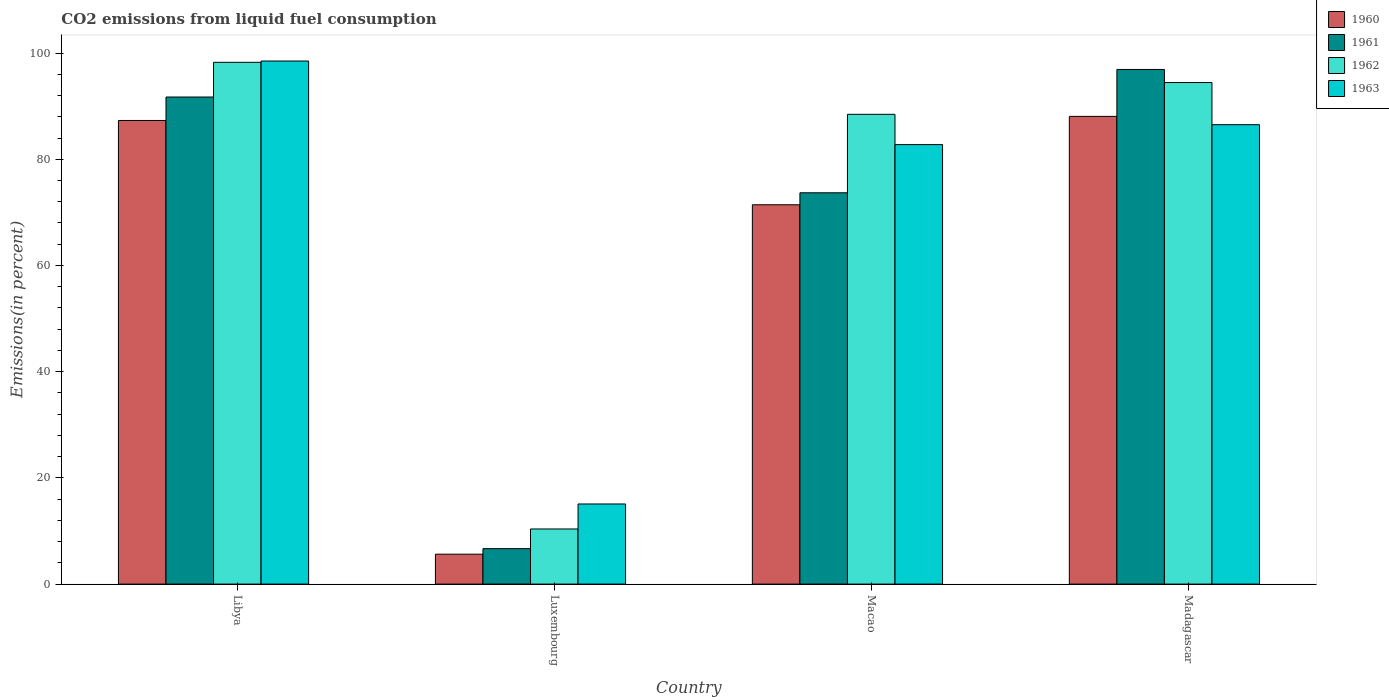How many bars are there on the 3rd tick from the left?
Provide a succinct answer. 4. What is the label of the 1st group of bars from the left?
Make the answer very short. Libya. What is the total CO2 emitted in 1963 in Libya?
Keep it short and to the point. 98.5. Across all countries, what is the maximum total CO2 emitted in 1962?
Your answer should be very brief. 98.25. Across all countries, what is the minimum total CO2 emitted in 1962?
Offer a terse response. 10.38. In which country was the total CO2 emitted in 1963 maximum?
Offer a terse response. Libya. In which country was the total CO2 emitted in 1961 minimum?
Provide a succinct answer. Luxembourg. What is the total total CO2 emitted in 1961 in the graph?
Give a very brief answer. 268.98. What is the difference between the total CO2 emitted in 1961 in Luxembourg and that in Madagascar?
Your answer should be very brief. -90.23. What is the difference between the total CO2 emitted in 1962 in Luxembourg and the total CO2 emitted in 1961 in Madagascar?
Provide a succinct answer. -86.53. What is the average total CO2 emitted in 1963 per country?
Your answer should be compact. 70.71. What is the difference between the total CO2 emitted of/in 1962 and total CO2 emitted of/in 1961 in Macao?
Your answer should be very brief. 14.78. What is the ratio of the total CO2 emitted in 1962 in Macao to that in Madagascar?
Ensure brevity in your answer.  0.94. Is the total CO2 emitted in 1960 in Libya less than that in Macao?
Your answer should be compact. No. What is the difference between the highest and the second highest total CO2 emitted in 1960?
Give a very brief answer. 16.64. What is the difference between the highest and the lowest total CO2 emitted in 1960?
Ensure brevity in your answer.  82.44. In how many countries, is the total CO2 emitted in 1962 greater than the average total CO2 emitted in 1962 taken over all countries?
Offer a very short reply. 3. Is it the case that in every country, the sum of the total CO2 emitted in 1962 and total CO2 emitted in 1961 is greater than the sum of total CO2 emitted in 1960 and total CO2 emitted in 1963?
Your answer should be very brief. No. How many bars are there?
Provide a succinct answer. 16. Are all the bars in the graph horizontal?
Give a very brief answer. No. Are the values on the major ticks of Y-axis written in scientific E-notation?
Your answer should be compact. No. Does the graph contain any zero values?
Give a very brief answer. No. Where does the legend appear in the graph?
Your answer should be very brief. Top right. How many legend labels are there?
Make the answer very short. 4. What is the title of the graph?
Provide a succinct answer. CO2 emissions from liquid fuel consumption. What is the label or title of the Y-axis?
Offer a terse response. Emissions(in percent). What is the Emissions(in percent) of 1960 in Libya?
Your answer should be very brief. 87.3. What is the Emissions(in percent) in 1961 in Libya?
Provide a succinct answer. 91.72. What is the Emissions(in percent) in 1962 in Libya?
Your answer should be compact. 98.25. What is the Emissions(in percent) of 1963 in Libya?
Make the answer very short. 98.5. What is the Emissions(in percent) of 1960 in Luxembourg?
Your answer should be very brief. 5.64. What is the Emissions(in percent) of 1961 in Luxembourg?
Your response must be concise. 6.68. What is the Emissions(in percent) of 1962 in Luxembourg?
Ensure brevity in your answer.  10.38. What is the Emissions(in percent) of 1963 in Luxembourg?
Keep it short and to the point. 15.09. What is the Emissions(in percent) in 1960 in Macao?
Give a very brief answer. 71.43. What is the Emissions(in percent) in 1961 in Macao?
Provide a succinct answer. 73.68. What is the Emissions(in percent) in 1962 in Macao?
Keep it short and to the point. 88.46. What is the Emissions(in percent) in 1963 in Macao?
Provide a succinct answer. 82.76. What is the Emissions(in percent) of 1960 in Madagascar?
Make the answer very short. 88.07. What is the Emissions(in percent) of 1961 in Madagascar?
Your response must be concise. 96.91. What is the Emissions(in percent) of 1962 in Madagascar?
Give a very brief answer. 94.44. What is the Emissions(in percent) of 1963 in Madagascar?
Keep it short and to the point. 86.51. Across all countries, what is the maximum Emissions(in percent) of 1960?
Offer a terse response. 88.07. Across all countries, what is the maximum Emissions(in percent) of 1961?
Make the answer very short. 96.91. Across all countries, what is the maximum Emissions(in percent) of 1962?
Offer a terse response. 98.25. Across all countries, what is the maximum Emissions(in percent) of 1963?
Provide a short and direct response. 98.5. Across all countries, what is the minimum Emissions(in percent) in 1960?
Provide a short and direct response. 5.64. Across all countries, what is the minimum Emissions(in percent) in 1961?
Provide a short and direct response. 6.68. Across all countries, what is the minimum Emissions(in percent) of 1962?
Offer a terse response. 10.38. Across all countries, what is the minimum Emissions(in percent) of 1963?
Offer a terse response. 15.09. What is the total Emissions(in percent) of 1960 in the graph?
Keep it short and to the point. 252.44. What is the total Emissions(in percent) in 1961 in the graph?
Offer a very short reply. 268.98. What is the total Emissions(in percent) in 1962 in the graph?
Provide a short and direct response. 291.54. What is the total Emissions(in percent) of 1963 in the graph?
Give a very brief answer. 282.85. What is the difference between the Emissions(in percent) in 1960 in Libya and that in Luxembourg?
Ensure brevity in your answer.  81.67. What is the difference between the Emissions(in percent) of 1961 in Libya and that in Luxembourg?
Provide a succinct answer. 85.04. What is the difference between the Emissions(in percent) in 1962 in Libya and that in Luxembourg?
Offer a very short reply. 87.87. What is the difference between the Emissions(in percent) in 1963 in Libya and that in Luxembourg?
Offer a terse response. 83.41. What is the difference between the Emissions(in percent) of 1960 in Libya and that in Macao?
Keep it short and to the point. 15.87. What is the difference between the Emissions(in percent) in 1961 in Libya and that in Macao?
Give a very brief answer. 18.03. What is the difference between the Emissions(in percent) of 1962 in Libya and that in Macao?
Ensure brevity in your answer.  9.79. What is the difference between the Emissions(in percent) in 1963 in Libya and that in Macao?
Offer a very short reply. 15.74. What is the difference between the Emissions(in percent) in 1960 in Libya and that in Madagascar?
Make the answer very short. -0.77. What is the difference between the Emissions(in percent) in 1961 in Libya and that in Madagascar?
Offer a very short reply. -5.19. What is the difference between the Emissions(in percent) in 1962 in Libya and that in Madagascar?
Your response must be concise. 3.81. What is the difference between the Emissions(in percent) of 1963 in Libya and that in Madagascar?
Give a very brief answer. 11.99. What is the difference between the Emissions(in percent) of 1960 in Luxembourg and that in Macao?
Offer a terse response. -65.79. What is the difference between the Emissions(in percent) in 1961 in Luxembourg and that in Macao?
Ensure brevity in your answer.  -67.01. What is the difference between the Emissions(in percent) of 1962 in Luxembourg and that in Macao?
Your response must be concise. -78.08. What is the difference between the Emissions(in percent) in 1963 in Luxembourg and that in Macao?
Your answer should be very brief. -67.67. What is the difference between the Emissions(in percent) of 1960 in Luxembourg and that in Madagascar?
Ensure brevity in your answer.  -82.44. What is the difference between the Emissions(in percent) of 1961 in Luxembourg and that in Madagascar?
Your answer should be very brief. -90.23. What is the difference between the Emissions(in percent) of 1962 in Luxembourg and that in Madagascar?
Ensure brevity in your answer.  -84.06. What is the difference between the Emissions(in percent) of 1963 in Luxembourg and that in Madagascar?
Your answer should be very brief. -71.42. What is the difference between the Emissions(in percent) in 1960 in Macao and that in Madagascar?
Give a very brief answer. -16.64. What is the difference between the Emissions(in percent) of 1961 in Macao and that in Madagascar?
Make the answer very short. -23.22. What is the difference between the Emissions(in percent) in 1962 in Macao and that in Madagascar?
Make the answer very short. -5.98. What is the difference between the Emissions(in percent) in 1963 in Macao and that in Madagascar?
Your answer should be compact. -3.75. What is the difference between the Emissions(in percent) in 1960 in Libya and the Emissions(in percent) in 1961 in Luxembourg?
Ensure brevity in your answer.  80.63. What is the difference between the Emissions(in percent) in 1960 in Libya and the Emissions(in percent) in 1962 in Luxembourg?
Your answer should be compact. 76.92. What is the difference between the Emissions(in percent) of 1960 in Libya and the Emissions(in percent) of 1963 in Luxembourg?
Provide a short and direct response. 72.22. What is the difference between the Emissions(in percent) of 1961 in Libya and the Emissions(in percent) of 1962 in Luxembourg?
Offer a very short reply. 81.34. What is the difference between the Emissions(in percent) in 1961 in Libya and the Emissions(in percent) in 1963 in Luxembourg?
Offer a very short reply. 76.63. What is the difference between the Emissions(in percent) of 1962 in Libya and the Emissions(in percent) of 1963 in Luxembourg?
Make the answer very short. 83.17. What is the difference between the Emissions(in percent) in 1960 in Libya and the Emissions(in percent) in 1961 in Macao?
Keep it short and to the point. 13.62. What is the difference between the Emissions(in percent) in 1960 in Libya and the Emissions(in percent) in 1962 in Macao?
Make the answer very short. -1.16. What is the difference between the Emissions(in percent) of 1960 in Libya and the Emissions(in percent) of 1963 in Macao?
Give a very brief answer. 4.54. What is the difference between the Emissions(in percent) of 1961 in Libya and the Emissions(in percent) of 1962 in Macao?
Provide a succinct answer. 3.26. What is the difference between the Emissions(in percent) in 1961 in Libya and the Emissions(in percent) in 1963 in Macao?
Provide a succinct answer. 8.96. What is the difference between the Emissions(in percent) of 1962 in Libya and the Emissions(in percent) of 1963 in Macao?
Provide a succinct answer. 15.49. What is the difference between the Emissions(in percent) in 1960 in Libya and the Emissions(in percent) in 1961 in Madagascar?
Keep it short and to the point. -9.61. What is the difference between the Emissions(in percent) in 1960 in Libya and the Emissions(in percent) in 1962 in Madagascar?
Your response must be concise. -7.14. What is the difference between the Emissions(in percent) in 1960 in Libya and the Emissions(in percent) in 1963 in Madagascar?
Make the answer very short. 0.79. What is the difference between the Emissions(in percent) in 1961 in Libya and the Emissions(in percent) in 1962 in Madagascar?
Your answer should be compact. -2.73. What is the difference between the Emissions(in percent) in 1961 in Libya and the Emissions(in percent) in 1963 in Madagascar?
Offer a very short reply. 5.21. What is the difference between the Emissions(in percent) in 1962 in Libya and the Emissions(in percent) in 1963 in Madagascar?
Your response must be concise. 11.74. What is the difference between the Emissions(in percent) of 1960 in Luxembourg and the Emissions(in percent) of 1961 in Macao?
Provide a succinct answer. -68.05. What is the difference between the Emissions(in percent) of 1960 in Luxembourg and the Emissions(in percent) of 1962 in Macao?
Your answer should be very brief. -82.83. What is the difference between the Emissions(in percent) of 1960 in Luxembourg and the Emissions(in percent) of 1963 in Macao?
Give a very brief answer. -77.12. What is the difference between the Emissions(in percent) of 1961 in Luxembourg and the Emissions(in percent) of 1962 in Macao?
Provide a succinct answer. -81.79. What is the difference between the Emissions(in percent) in 1961 in Luxembourg and the Emissions(in percent) in 1963 in Macao?
Provide a short and direct response. -76.08. What is the difference between the Emissions(in percent) of 1962 in Luxembourg and the Emissions(in percent) of 1963 in Macao?
Provide a succinct answer. -72.38. What is the difference between the Emissions(in percent) in 1960 in Luxembourg and the Emissions(in percent) in 1961 in Madagascar?
Your answer should be compact. -91.27. What is the difference between the Emissions(in percent) of 1960 in Luxembourg and the Emissions(in percent) of 1962 in Madagascar?
Make the answer very short. -88.81. What is the difference between the Emissions(in percent) in 1960 in Luxembourg and the Emissions(in percent) in 1963 in Madagascar?
Make the answer very short. -80.87. What is the difference between the Emissions(in percent) of 1961 in Luxembourg and the Emissions(in percent) of 1962 in Madagascar?
Your answer should be very brief. -87.77. What is the difference between the Emissions(in percent) in 1961 in Luxembourg and the Emissions(in percent) in 1963 in Madagascar?
Give a very brief answer. -79.83. What is the difference between the Emissions(in percent) in 1962 in Luxembourg and the Emissions(in percent) in 1963 in Madagascar?
Ensure brevity in your answer.  -76.13. What is the difference between the Emissions(in percent) in 1960 in Macao and the Emissions(in percent) in 1961 in Madagascar?
Provide a succinct answer. -25.48. What is the difference between the Emissions(in percent) in 1960 in Macao and the Emissions(in percent) in 1962 in Madagascar?
Keep it short and to the point. -23.02. What is the difference between the Emissions(in percent) in 1960 in Macao and the Emissions(in percent) in 1963 in Madagascar?
Keep it short and to the point. -15.08. What is the difference between the Emissions(in percent) in 1961 in Macao and the Emissions(in percent) in 1962 in Madagascar?
Your response must be concise. -20.76. What is the difference between the Emissions(in percent) of 1961 in Macao and the Emissions(in percent) of 1963 in Madagascar?
Offer a terse response. -12.82. What is the difference between the Emissions(in percent) in 1962 in Macao and the Emissions(in percent) in 1963 in Madagascar?
Make the answer very short. 1.95. What is the average Emissions(in percent) in 1960 per country?
Provide a succinct answer. 63.11. What is the average Emissions(in percent) of 1961 per country?
Offer a very short reply. 67.25. What is the average Emissions(in percent) of 1962 per country?
Make the answer very short. 72.88. What is the average Emissions(in percent) of 1963 per country?
Your response must be concise. 70.71. What is the difference between the Emissions(in percent) of 1960 and Emissions(in percent) of 1961 in Libya?
Your answer should be compact. -4.42. What is the difference between the Emissions(in percent) in 1960 and Emissions(in percent) in 1962 in Libya?
Make the answer very short. -10.95. What is the difference between the Emissions(in percent) of 1960 and Emissions(in percent) of 1963 in Libya?
Provide a short and direct response. -11.19. What is the difference between the Emissions(in percent) in 1961 and Emissions(in percent) in 1962 in Libya?
Provide a succinct answer. -6.53. What is the difference between the Emissions(in percent) in 1961 and Emissions(in percent) in 1963 in Libya?
Your answer should be very brief. -6.78. What is the difference between the Emissions(in percent) in 1962 and Emissions(in percent) in 1963 in Libya?
Offer a very short reply. -0.24. What is the difference between the Emissions(in percent) in 1960 and Emissions(in percent) in 1961 in Luxembourg?
Your answer should be very brief. -1.04. What is the difference between the Emissions(in percent) of 1960 and Emissions(in percent) of 1962 in Luxembourg?
Give a very brief answer. -4.75. What is the difference between the Emissions(in percent) of 1960 and Emissions(in percent) of 1963 in Luxembourg?
Offer a very short reply. -9.45. What is the difference between the Emissions(in percent) of 1961 and Emissions(in percent) of 1962 in Luxembourg?
Your answer should be very brief. -3.71. What is the difference between the Emissions(in percent) of 1961 and Emissions(in percent) of 1963 in Luxembourg?
Your answer should be very brief. -8.41. What is the difference between the Emissions(in percent) in 1962 and Emissions(in percent) in 1963 in Luxembourg?
Your answer should be very brief. -4.71. What is the difference between the Emissions(in percent) in 1960 and Emissions(in percent) in 1961 in Macao?
Give a very brief answer. -2.26. What is the difference between the Emissions(in percent) of 1960 and Emissions(in percent) of 1962 in Macao?
Keep it short and to the point. -17.03. What is the difference between the Emissions(in percent) of 1960 and Emissions(in percent) of 1963 in Macao?
Provide a short and direct response. -11.33. What is the difference between the Emissions(in percent) in 1961 and Emissions(in percent) in 1962 in Macao?
Give a very brief answer. -14.78. What is the difference between the Emissions(in percent) in 1961 and Emissions(in percent) in 1963 in Macao?
Offer a terse response. -9.07. What is the difference between the Emissions(in percent) in 1962 and Emissions(in percent) in 1963 in Macao?
Your answer should be very brief. 5.7. What is the difference between the Emissions(in percent) of 1960 and Emissions(in percent) of 1961 in Madagascar?
Ensure brevity in your answer.  -8.83. What is the difference between the Emissions(in percent) in 1960 and Emissions(in percent) in 1962 in Madagascar?
Provide a short and direct response. -6.37. What is the difference between the Emissions(in percent) in 1960 and Emissions(in percent) in 1963 in Madagascar?
Provide a succinct answer. 1.57. What is the difference between the Emissions(in percent) of 1961 and Emissions(in percent) of 1962 in Madagascar?
Provide a succinct answer. 2.46. What is the difference between the Emissions(in percent) of 1961 and Emissions(in percent) of 1963 in Madagascar?
Your answer should be compact. 10.4. What is the difference between the Emissions(in percent) of 1962 and Emissions(in percent) of 1963 in Madagascar?
Ensure brevity in your answer.  7.94. What is the ratio of the Emissions(in percent) in 1960 in Libya to that in Luxembourg?
Make the answer very short. 15.49. What is the ratio of the Emissions(in percent) in 1961 in Libya to that in Luxembourg?
Offer a very short reply. 13.74. What is the ratio of the Emissions(in percent) in 1962 in Libya to that in Luxembourg?
Make the answer very short. 9.46. What is the ratio of the Emissions(in percent) in 1963 in Libya to that in Luxembourg?
Offer a very short reply. 6.53. What is the ratio of the Emissions(in percent) in 1960 in Libya to that in Macao?
Your response must be concise. 1.22. What is the ratio of the Emissions(in percent) of 1961 in Libya to that in Macao?
Ensure brevity in your answer.  1.24. What is the ratio of the Emissions(in percent) of 1962 in Libya to that in Macao?
Your response must be concise. 1.11. What is the ratio of the Emissions(in percent) of 1963 in Libya to that in Macao?
Your answer should be compact. 1.19. What is the ratio of the Emissions(in percent) of 1961 in Libya to that in Madagascar?
Provide a short and direct response. 0.95. What is the ratio of the Emissions(in percent) in 1962 in Libya to that in Madagascar?
Provide a short and direct response. 1.04. What is the ratio of the Emissions(in percent) of 1963 in Libya to that in Madagascar?
Keep it short and to the point. 1.14. What is the ratio of the Emissions(in percent) in 1960 in Luxembourg to that in Macao?
Your response must be concise. 0.08. What is the ratio of the Emissions(in percent) in 1961 in Luxembourg to that in Macao?
Offer a very short reply. 0.09. What is the ratio of the Emissions(in percent) of 1962 in Luxembourg to that in Macao?
Your answer should be compact. 0.12. What is the ratio of the Emissions(in percent) of 1963 in Luxembourg to that in Macao?
Give a very brief answer. 0.18. What is the ratio of the Emissions(in percent) of 1960 in Luxembourg to that in Madagascar?
Ensure brevity in your answer.  0.06. What is the ratio of the Emissions(in percent) of 1961 in Luxembourg to that in Madagascar?
Offer a very short reply. 0.07. What is the ratio of the Emissions(in percent) of 1962 in Luxembourg to that in Madagascar?
Ensure brevity in your answer.  0.11. What is the ratio of the Emissions(in percent) in 1963 in Luxembourg to that in Madagascar?
Your answer should be very brief. 0.17. What is the ratio of the Emissions(in percent) in 1960 in Macao to that in Madagascar?
Your answer should be very brief. 0.81. What is the ratio of the Emissions(in percent) of 1961 in Macao to that in Madagascar?
Offer a very short reply. 0.76. What is the ratio of the Emissions(in percent) in 1962 in Macao to that in Madagascar?
Your response must be concise. 0.94. What is the ratio of the Emissions(in percent) in 1963 in Macao to that in Madagascar?
Ensure brevity in your answer.  0.96. What is the difference between the highest and the second highest Emissions(in percent) of 1960?
Make the answer very short. 0.77. What is the difference between the highest and the second highest Emissions(in percent) in 1961?
Your answer should be very brief. 5.19. What is the difference between the highest and the second highest Emissions(in percent) of 1962?
Your answer should be very brief. 3.81. What is the difference between the highest and the second highest Emissions(in percent) of 1963?
Make the answer very short. 11.99. What is the difference between the highest and the lowest Emissions(in percent) in 1960?
Your answer should be compact. 82.44. What is the difference between the highest and the lowest Emissions(in percent) of 1961?
Your answer should be compact. 90.23. What is the difference between the highest and the lowest Emissions(in percent) of 1962?
Ensure brevity in your answer.  87.87. What is the difference between the highest and the lowest Emissions(in percent) in 1963?
Your response must be concise. 83.41. 